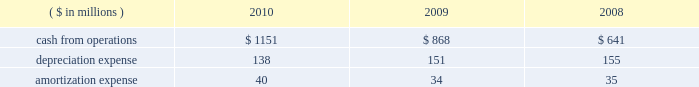During 2010 , we granted 3.8 million rsus and 1.1 million employee sars .
See footnote no .
4 , 201cshare-based compensation , 201d of the notes to our financial statements for additional information .
New accounting standards see footnote no .
1 , 201csummary of significant accounting policies , 201d of the notes to our financial statements for information related to our adoption of new accounting standards in 2010 and for information on our anticipated adoption of recently issued accounting standards .
Liquidity and capital resources cash requirements and our credit facilities our credit facility , which expires on may 14 , 2012 , and associated letters of credit , provide for $ 2.4 billion of aggregate effective borrowings .
Borrowings under the credit facility bear interest at the london interbank offered rate ( libor ) plus a fixed spread based on the credit ratings for our public debt .
We also pay quarterly fees on the credit facility at a rate based on our public debt rating .
For additional information on our credit facility , including participating financial institutions , see exhibit 10 , 201camended and restated credit agreement , 201d to our current report on form 8-k filed with the sec on may 16 , 2007 .
Although our credit facility does not expire until 2012 , we expect that we may extend or replace it during 2011 .
The credit facility contains certain covenants , including a single financial covenant that limits our maximum leverage ( consisting of adjusted total debt to consolidated ebitda , each as defined in the credit facility ) to not more than 4 to 1 .
Our outstanding public debt does not contain a corresponding financial covenant or a requirement that we maintain certain financial ratios .
We currently satisfy the covenants in our credit facility and public debt instruments , including the leverage covenant under the credit facility , and do not expect the covenants to restrict our ability to meet our anticipated borrowing and guarantee levels or increase those levels should we need to do so in the future .
We believe the credit facility , together with cash we expect to generate from operations and our ability to raise capital , remains adequate to meet our short-term and long-term liquidity requirements , finance our long-term growth plans , meet debt service , and fulfill other cash requirements .
At year-end 2010 , our available borrowing capacity amounted to $ 2.831 billion and reflected borrowing capacity of $ 2.326 billion under our credit facility and our cash balance of $ 505 million .
We calculate that borrowing capacity by taking $ 2.404 billion of effective aggregate bank commitments under our credit facility and subtracting $ 78 million of outstanding letters of credit under our credit facility .
During 2010 , we repaid our outstanding credit facility borrowings and had no outstanding balance at year-end .
As noted in the previous paragraphs , we anticipate that this available capacity will be adequate to fund our liquidity needs .
Since we continue to have ample flexibility under the credit facility 2019s covenants , we also expect that undrawn bank commitments under the credit facility will remain available to us even if business conditions were to deteriorate markedly .
Cash from operations cash from operations , depreciation expense , and amortization expense for the last three fiscal years are as follows : ( $ in millions ) 2010 2009 2008 .
Our ratio of current assets to current liabilities was roughly 1.4 to 1.0 at year-end 2010 and 1.2 to 1.0 at year-end 2009 .
We minimize working capital through cash management , strict credit-granting policies , and aggressive collection efforts .
We also have significant borrowing capacity under our credit facility should we need additional working capital. .
What was the percentage change in cash from operations between 2008 and 2009? 
Computations: ((868 - 641) / 641)
Answer: 0.35413. 